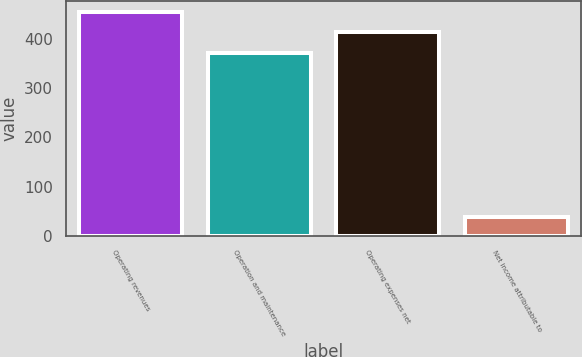Convert chart. <chart><loc_0><loc_0><loc_500><loc_500><bar_chart><fcel>Operating revenues<fcel>Operation and maintenance<fcel>Operating expenses net<fcel>Net income attributable to<nl><fcel>454.4<fcel>372<fcel>413.2<fcel>39<nl></chart> 